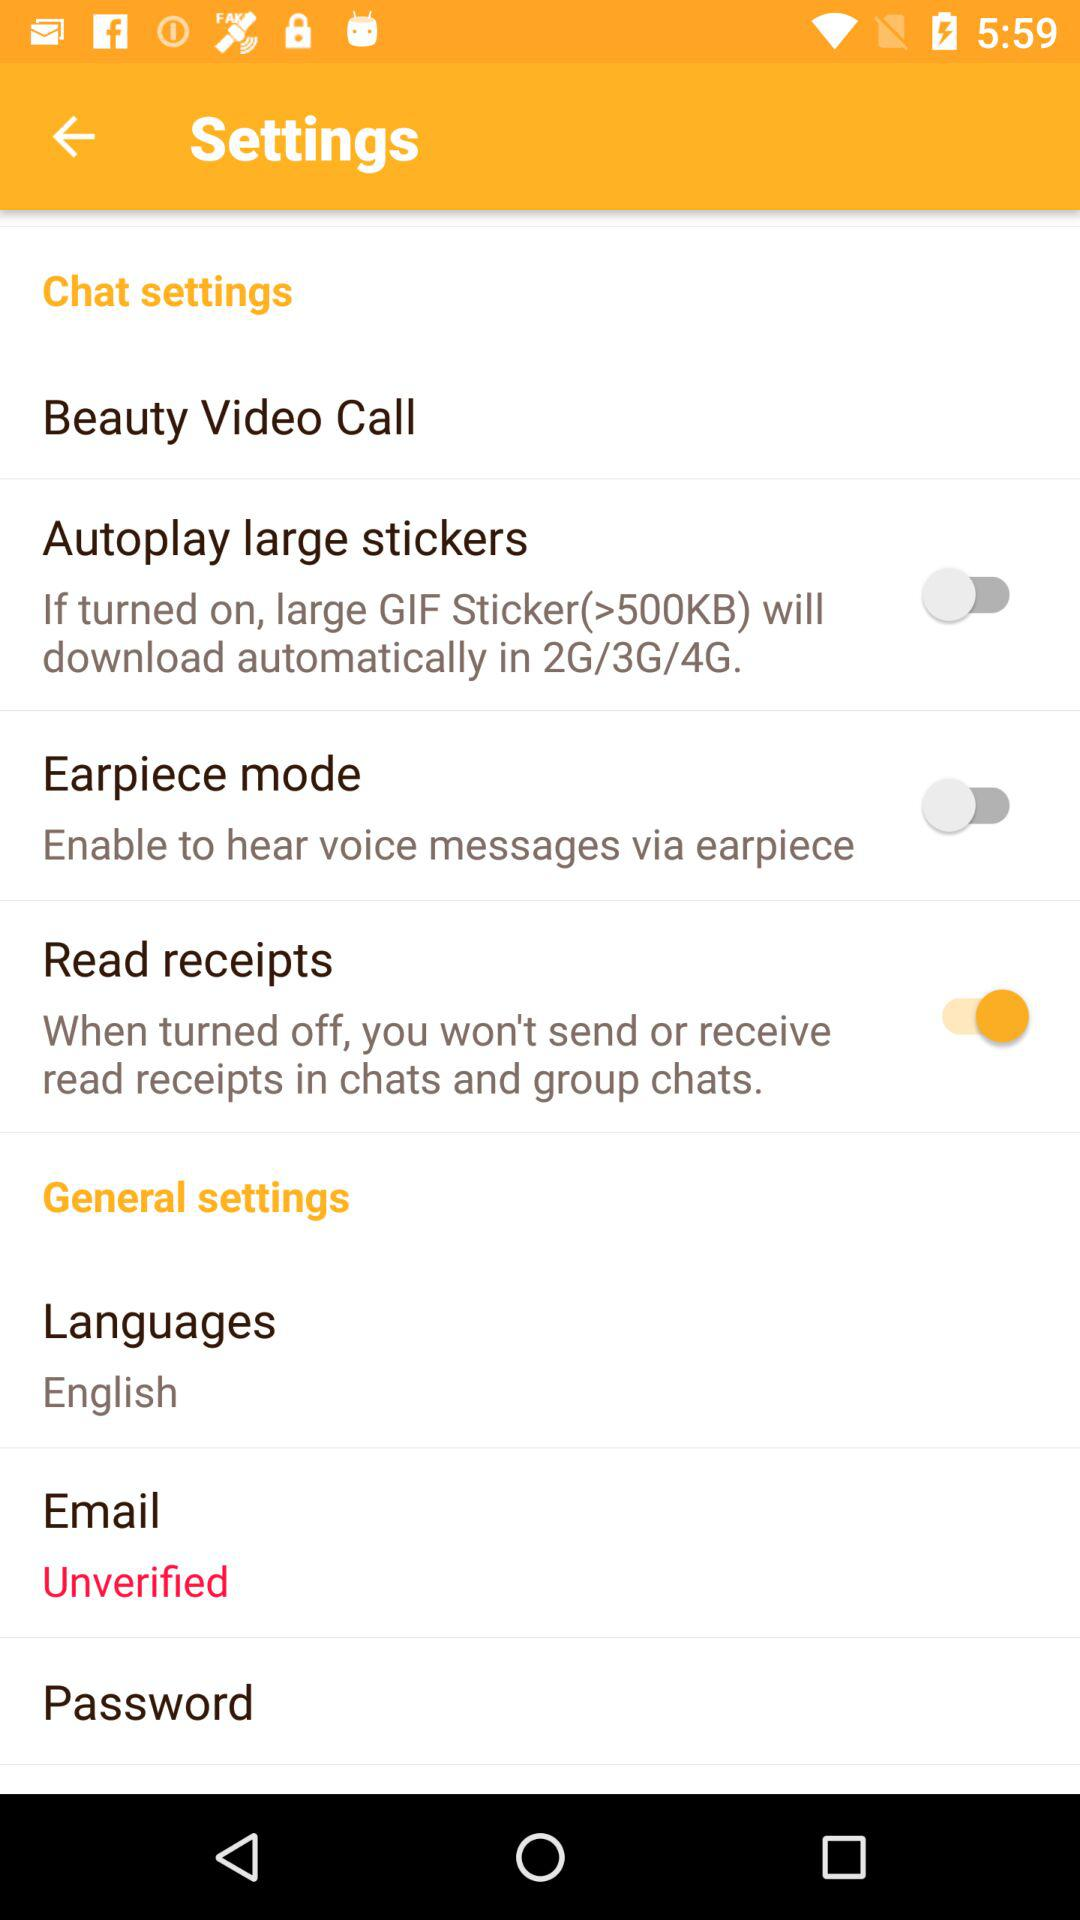What is the status of the "Earpiece mode" setting? The status is "off". 